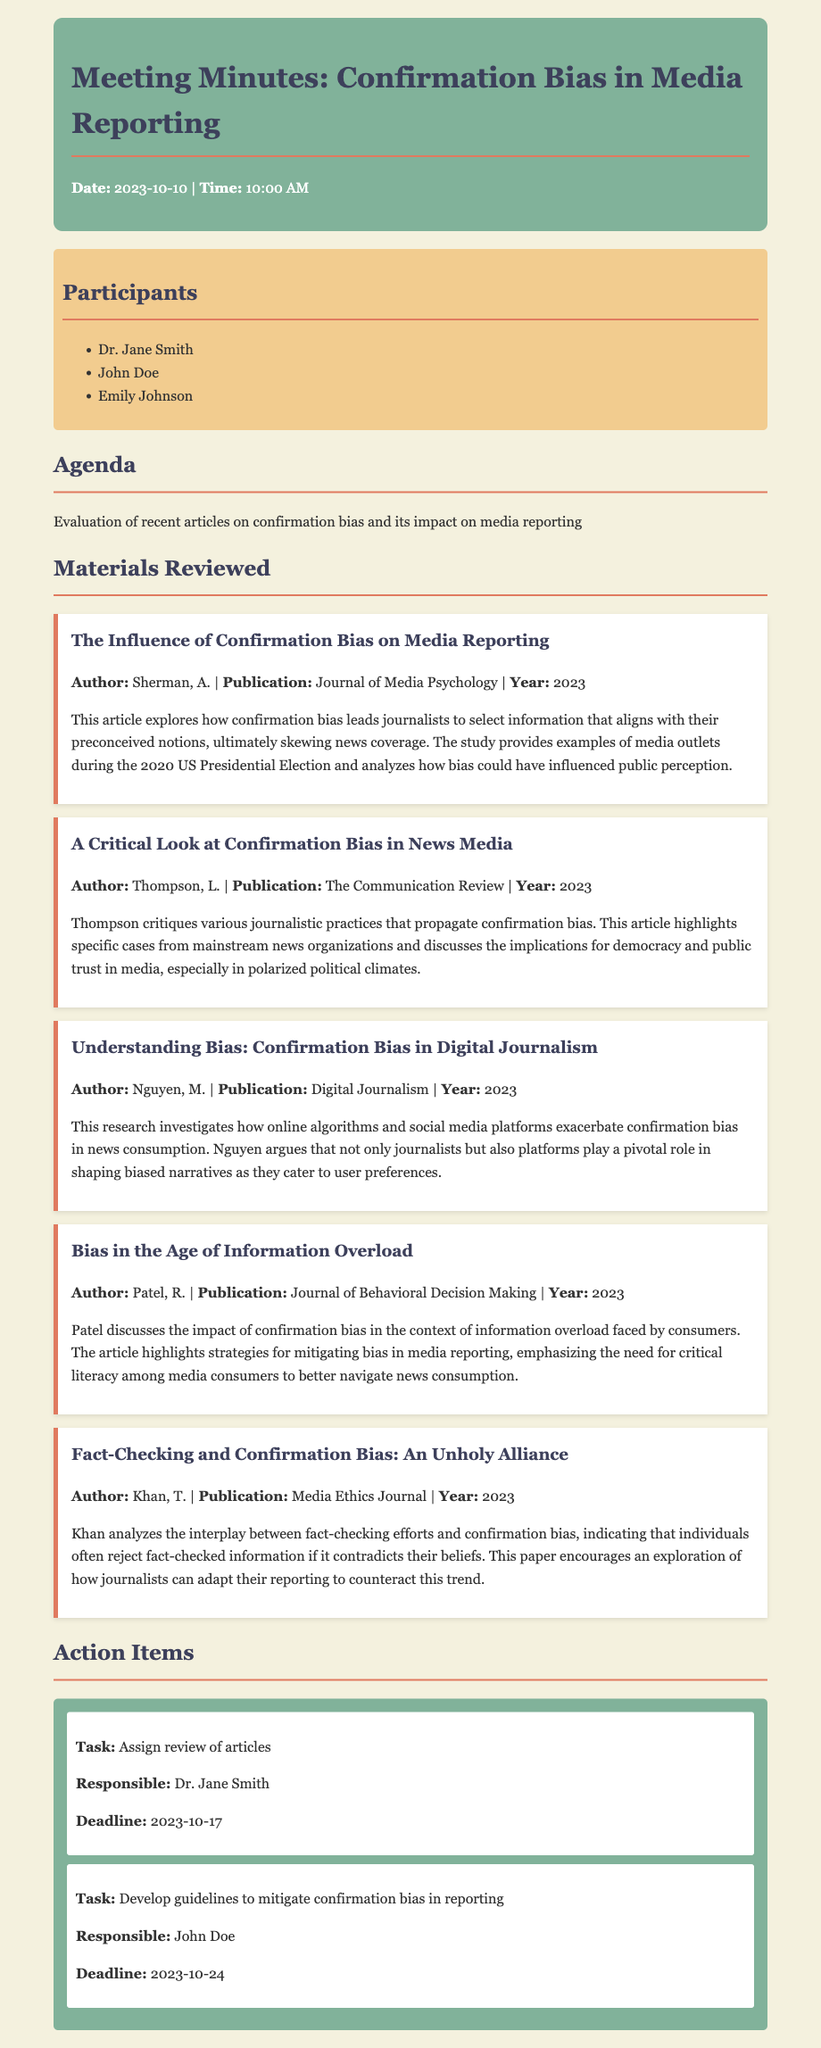what is the date of the meeting? The date of the meeting is specified at the top of the document.
Answer: 2023-10-10 who authored the article about media reporting during the 2020 US Presidential Election? The author of the article titled "The Influence of Confirmation Bias on Media Reporting" is mentioned in the materials section.
Answer: Sherman, A how many action items are listed in the document? The number of action items can be counted from the action items section.
Answer: 2 what was the focus of Thompson's article? The focus of Thompson's article can be inferred from the description provided under the materials reviewed.
Answer: Journalistic practices that propagate confirmation bias who is responsible for developing guidelines to mitigate confirmation bias? The responsible person for this action item is specified in the action items section.
Answer: John Doe which publication featured Khan's article? The publication name is mentioned under the article details in the materials reviewed.
Answer: Media Ethics Journal what deadline has been set for assigning the review of articles? The deadline is specified in the action item section of the document.
Answer: 2023-10-17 what is the main argument presented by Nguyen's research? The main argument can be derived from the abstract provided in the materials section.
Answer: Online algorithms and social media exacerbate confirmation bias 